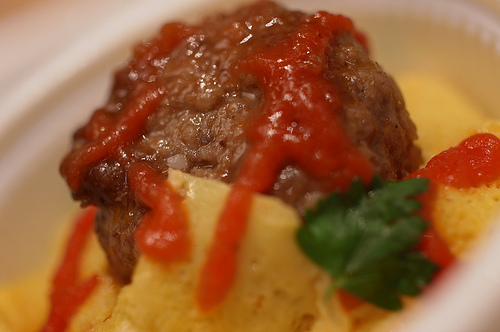<image>
Is there a sauce next to the cheese? Yes. The sauce is positioned adjacent to the cheese, located nearby in the same general area. 